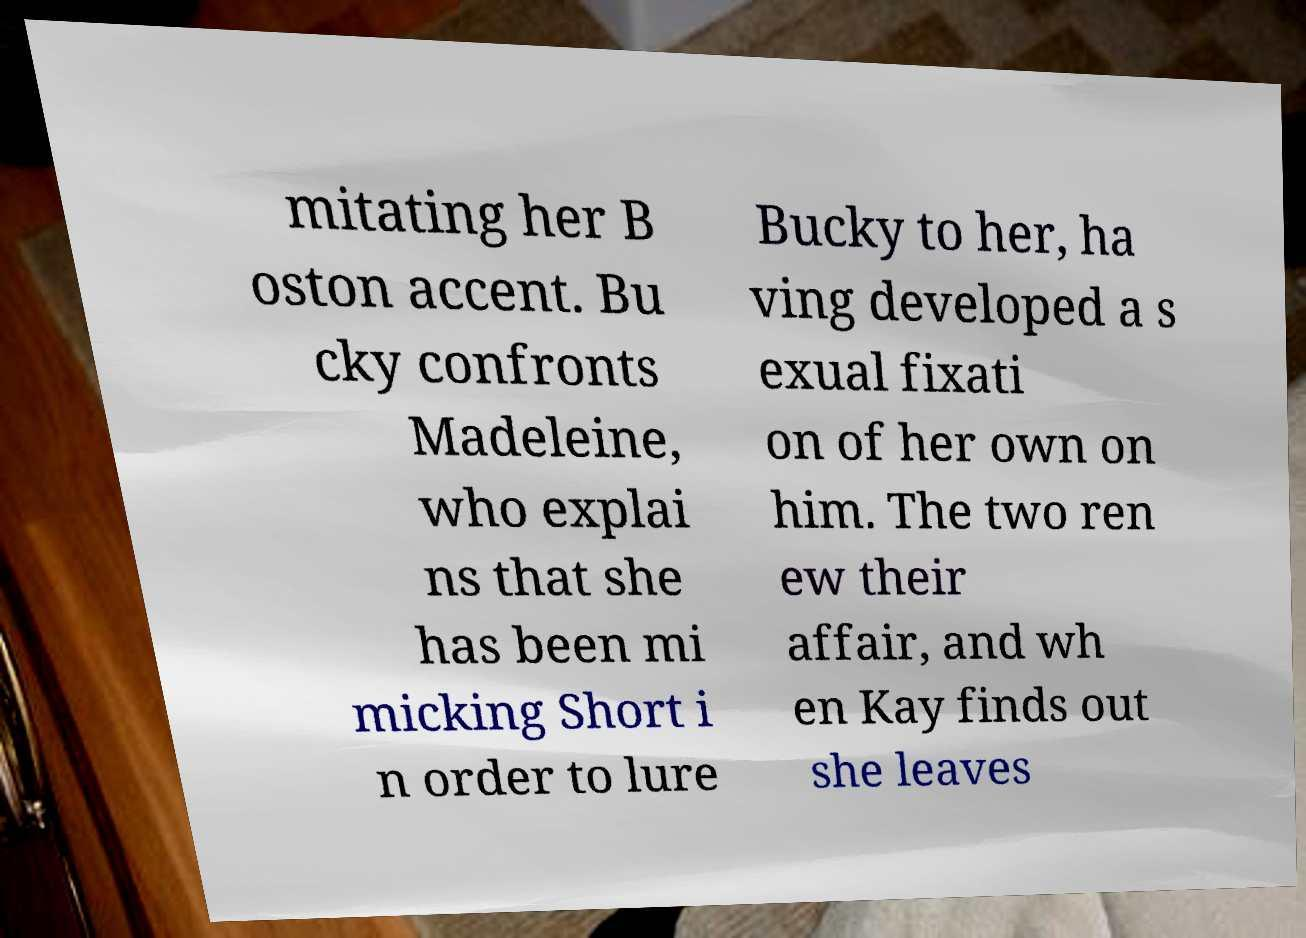Can you accurately transcribe the text from the provided image for me? mitating her B oston accent. Bu cky confronts Madeleine, who explai ns that she has been mi micking Short i n order to lure Bucky to her, ha ving developed a s exual fixati on of her own on him. The two ren ew their affair, and wh en Kay finds out she leaves 